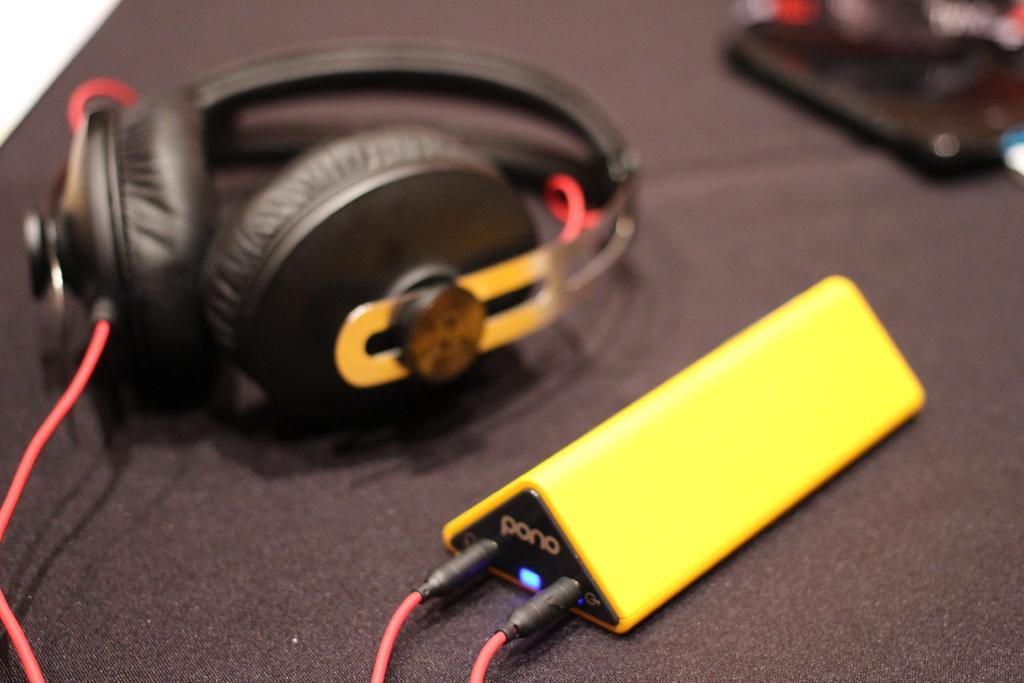Describe this image in one or two sentences. In this image I can see a headset. Also there is a digital music player. And the background is blurry. 